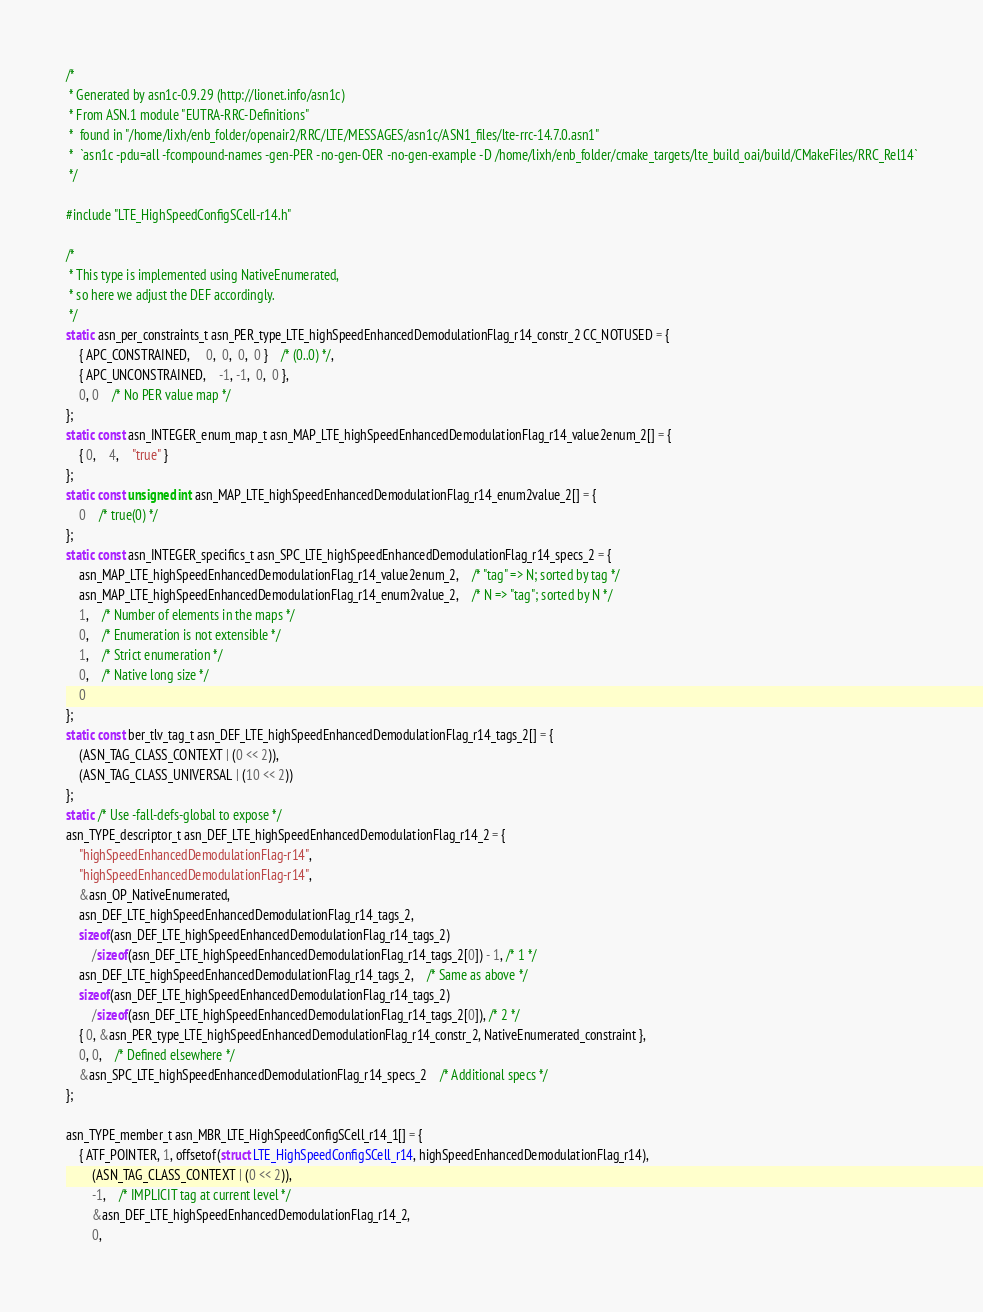<code> <loc_0><loc_0><loc_500><loc_500><_C_>/*
 * Generated by asn1c-0.9.29 (http://lionet.info/asn1c)
 * From ASN.1 module "EUTRA-RRC-Definitions"
 * 	found in "/home/lixh/enb_folder/openair2/RRC/LTE/MESSAGES/asn1c/ASN1_files/lte-rrc-14.7.0.asn1"
 * 	`asn1c -pdu=all -fcompound-names -gen-PER -no-gen-OER -no-gen-example -D /home/lixh/enb_folder/cmake_targets/lte_build_oai/build/CMakeFiles/RRC_Rel14`
 */

#include "LTE_HighSpeedConfigSCell-r14.h"

/*
 * This type is implemented using NativeEnumerated,
 * so here we adjust the DEF accordingly.
 */
static asn_per_constraints_t asn_PER_type_LTE_highSpeedEnhancedDemodulationFlag_r14_constr_2 CC_NOTUSED = {
	{ APC_CONSTRAINED,	 0,  0,  0,  0 }	/* (0..0) */,
	{ APC_UNCONSTRAINED,	-1, -1,  0,  0 },
	0, 0	/* No PER value map */
};
static const asn_INTEGER_enum_map_t asn_MAP_LTE_highSpeedEnhancedDemodulationFlag_r14_value2enum_2[] = {
	{ 0,	4,	"true" }
};
static const unsigned int asn_MAP_LTE_highSpeedEnhancedDemodulationFlag_r14_enum2value_2[] = {
	0	/* true(0) */
};
static const asn_INTEGER_specifics_t asn_SPC_LTE_highSpeedEnhancedDemodulationFlag_r14_specs_2 = {
	asn_MAP_LTE_highSpeedEnhancedDemodulationFlag_r14_value2enum_2,	/* "tag" => N; sorted by tag */
	asn_MAP_LTE_highSpeedEnhancedDemodulationFlag_r14_enum2value_2,	/* N => "tag"; sorted by N */
	1,	/* Number of elements in the maps */
	0,	/* Enumeration is not extensible */
	1,	/* Strict enumeration */
	0,	/* Native long size */
	0
};
static const ber_tlv_tag_t asn_DEF_LTE_highSpeedEnhancedDemodulationFlag_r14_tags_2[] = {
	(ASN_TAG_CLASS_CONTEXT | (0 << 2)),
	(ASN_TAG_CLASS_UNIVERSAL | (10 << 2))
};
static /* Use -fall-defs-global to expose */
asn_TYPE_descriptor_t asn_DEF_LTE_highSpeedEnhancedDemodulationFlag_r14_2 = {
	"highSpeedEnhancedDemodulationFlag-r14",
	"highSpeedEnhancedDemodulationFlag-r14",
	&asn_OP_NativeEnumerated,
	asn_DEF_LTE_highSpeedEnhancedDemodulationFlag_r14_tags_2,
	sizeof(asn_DEF_LTE_highSpeedEnhancedDemodulationFlag_r14_tags_2)
		/sizeof(asn_DEF_LTE_highSpeedEnhancedDemodulationFlag_r14_tags_2[0]) - 1, /* 1 */
	asn_DEF_LTE_highSpeedEnhancedDemodulationFlag_r14_tags_2,	/* Same as above */
	sizeof(asn_DEF_LTE_highSpeedEnhancedDemodulationFlag_r14_tags_2)
		/sizeof(asn_DEF_LTE_highSpeedEnhancedDemodulationFlag_r14_tags_2[0]), /* 2 */
	{ 0, &asn_PER_type_LTE_highSpeedEnhancedDemodulationFlag_r14_constr_2, NativeEnumerated_constraint },
	0, 0,	/* Defined elsewhere */
	&asn_SPC_LTE_highSpeedEnhancedDemodulationFlag_r14_specs_2	/* Additional specs */
};

asn_TYPE_member_t asn_MBR_LTE_HighSpeedConfigSCell_r14_1[] = {
	{ ATF_POINTER, 1, offsetof(struct LTE_HighSpeedConfigSCell_r14, highSpeedEnhancedDemodulationFlag_r14),
		(ASN_TAG_CLASS_CONTEXT | (0 << 2)),
		-1,	/* IMPLICIT tag at current level */
		&asn_DEF_LTE_highSpeedEnhancedDemodulationFlag_r14_2,
		0,</code> 